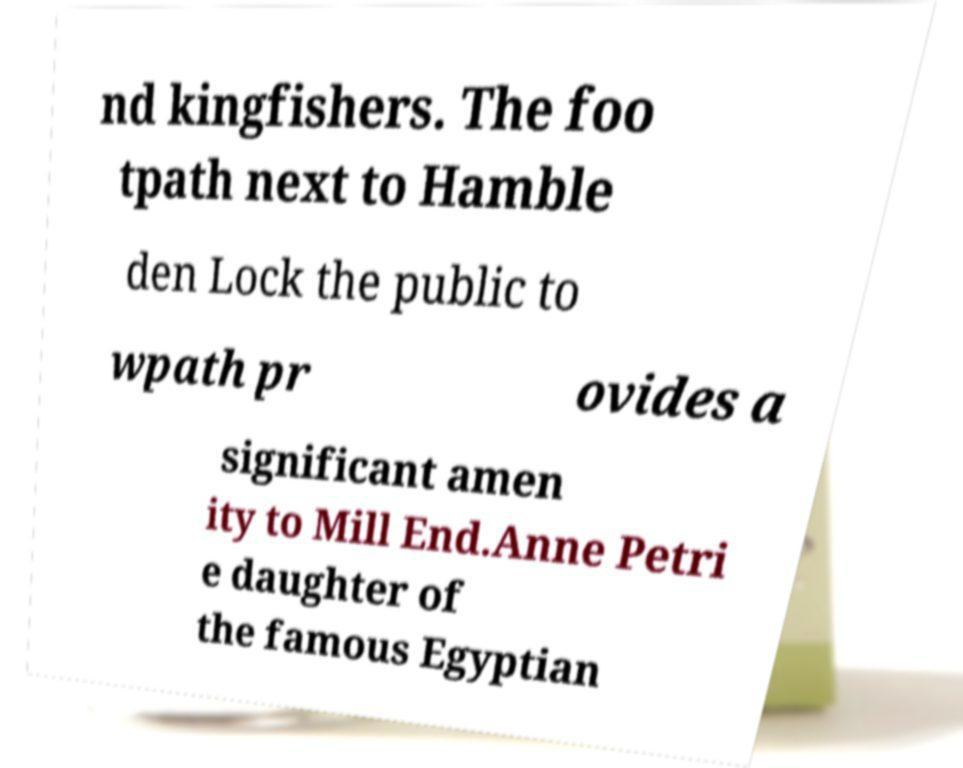Please read and relay the text visible in this image. What does it say? nd kingfishers. The foo tpath next to Hamble den Lock the public to wpath pr ovides a significant amen ity to Mill End.Anne Petri e daughter of the famous Egyptian 